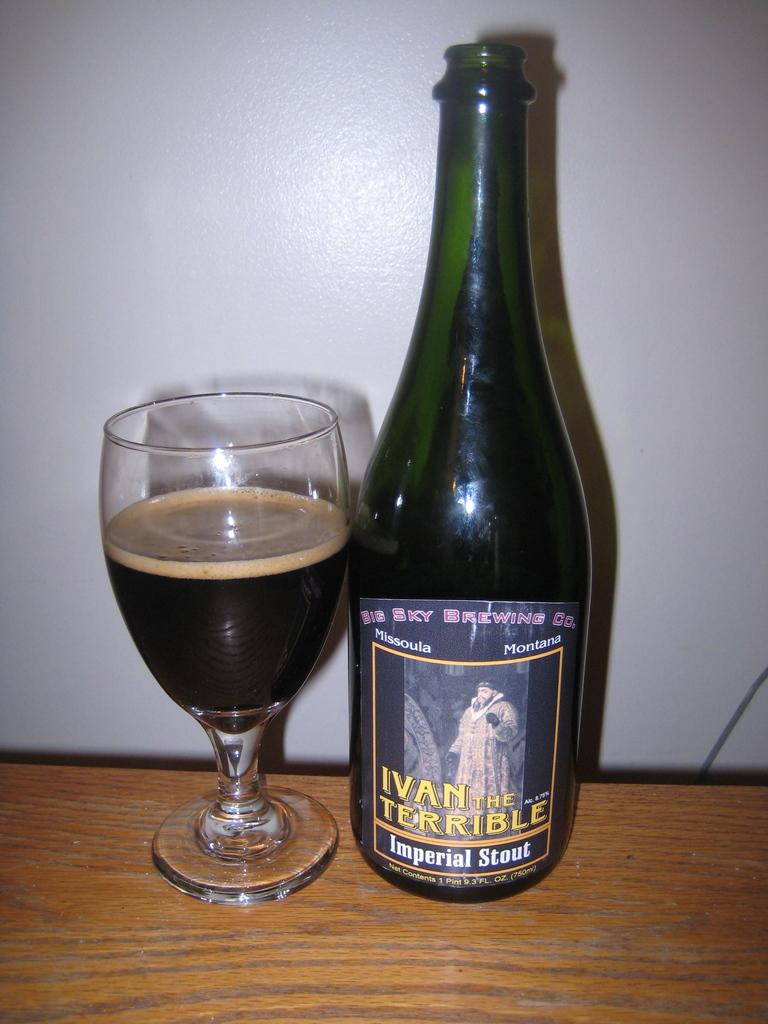<image>
Share a concise interpretation of the image provided. the word Ivan that is on a wine bottle 